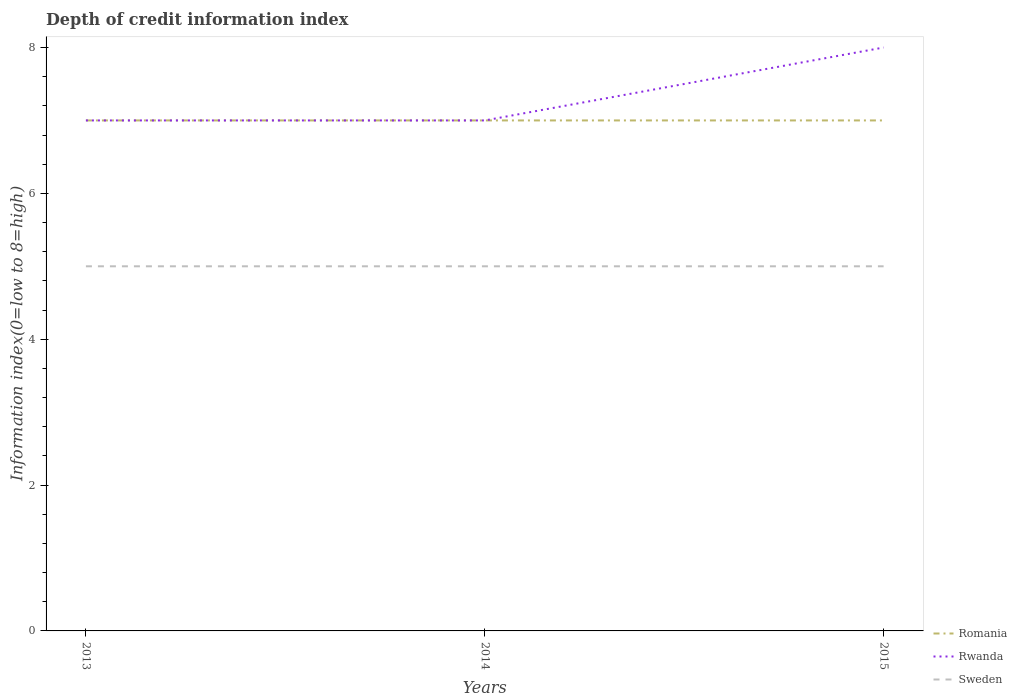How many different coloured lines are there?
Provide a short and direct response. 3. Does the line corresponding to Romania intersect with the line corresponding to Rwanda?
Provide a succinct answer. Yes. Is the number of lines equal to the number of legend labels?
Offer a very short reply. Yes. Across all years, what is the maximum information index in Romania?
Offer a very short reply. 7. What is the difference between the highest and the lowest information index in Romania?
Make the answer very short. 0. How many lines are there?
Make the answer very short. 3. Are the values on the major ticks of Y-axis written in scientific E-notation?
Offer a terse response. No. Does the graph contain any zero values?
Your response must be concise. No. Where does the legend appear in the graph?
Offer a terse response. Bottom right. How many legend labels are there?
Your response must be concise. 3. How are the legend labels stacked?
Keep it short and to the point. Vertical. What is the title of the graph?
Your answer should be compact. Depth of credit information index. What is the label or title of the X-axis?
Provide a short and direct response. Years. What is the label or title of the Y-axis?
Make the answer very short. Information index(0=low to 8=high). What is the Information index(0=low to 8=high) in Romania in 2013?
Provide a short and direct response. 7. What is the Information index(0=low to 8=high) in Sweden in 2013?
Ensure brevity in your answer.  5. What is the Information index(0=low to 8=high) of Romania in 2015?
Make the answer very short. 7. Across all years, what is the maximum Information index(0=low to 8=high) of Rwanda?
Give a very brief answer. 8. Across all years, what is the minimum Information index(0=low to 8=high) in Rwanda?
Provide a short and direct response. 7. What is the difference between the Information index(0=low to 8=high) in Romania in 2013 and that in 2014?
Your answer should be very brief. 0. What is the difference between the Information index(0=low to 8=high) in Sweden in 2013 and that in 2014?
Keep it short and to the point. 0. What is the difference between the Information index(0=low to 8=high) in Romania in 2013 and that in 2015?
Ensure brevity in your answer.  0. What is the difference between the Information index(0=low to 8=high) in Sweden in 2013 and that in 2015?
Ensure brevity in your answer.  0. What is the difference between the Information index(0=low to 8=high) of Sweden in 2014 and that in 2015?
Provide a short and direct response. 0. What is the difference between the Information index(0=low to 8=high) of Romania in 2013 and the Information index(0=low to 8=high) of Rwanda in 2014?
Provide a succinct answer. 0. What is the difference between the Information index(0=low to 8=high) in Rwanda in 2013 and the Information index(0=low to 8=high) in Sweden in 2014?
Provide a short and direct response. 2. What is the difference between the Information index(0=low to 8=high) of Romania in 2013 and the Information index(0=low to 8=high) of Sweden in 2015?
Keep it short and to the point. 2. What is the difference between the Information index(0=low to 8=high) of Rwanda in 2013 and the Information index(0=low to 8=high) of Sweden in 2015?
Provide a succinct answer. 2. What is the difference between the Information index(0=low to 8=high) in Romania in 2014 and the Information index(0=low to 8=high) in Rwanda in 2015?
Keep it short and to the point. -1. What is the difference between the Information index(0=low to 8=high) of Romania in 2014 and the Information index(0=low to 8=high) of Sweden in 2015?
Provide a short and direct response. 2. What is the average Information index(0=low to 8=high) of Romania per year?
Provide a short and direct response. 7. What is the average Information index(0=low to 8=high) of Rwanda per year?
Give a very brief answer. 7.33. What is the average Information index(0=low to 8=high) of Sweden per year?
Ensure brevity in your answer.  5. In the year 2013, what is the difference between the Information index(0=low to 8=high) of Romania and Information index(0=low to 8=high) of Rwanda?
Offer a terse response. 0. In the year 2013, what is the difference between the Information index(0=low to 8=high) of Romania and Information index(0=low to 8=high) of Sweden?
Your response must be concise. 2. In the year 2013, what is the difference between the Information index(0=low to 8=high) in Rwanda and Information index(0=low to 8=high) in Sweden?
Keep it short and to the point. 2. In the year 2014, what is the difference between the Information index(0=low to 8=high) in Romania and Information index(0=low to 8=high) in Sweden?
Offer a terse response. 2. In the year 2015, what is the difference between the Information index(0=low to 8=high) of Romania and Information index(0=low to 8=high) of Sweden?
Make the answer very short. 2. What is the ratio of the Information index(0=low to 8=high) in Romania in 2013 to that in 2014?
Your answer should be compact. 1. What is the ratio of the Information index(0=low to 8=high) in Sweden in 2013 to that in 2015?
Ensure brevity in your answer.  1. What is the ratio of the Information index(0=low to 8=high) of Romania in 2014 to that in 2015?
Offer a very short reply. 1. What is the ratio of the Information index(0=low to 8=high) in Rwanda in 2014 to that in 2015?
Your answer should be compact. 0.88. What is the difference between the highest and the second highest Information index(0=low to 8=high) in Rwanda?
Your answer should be compact. 1. What is the difference between the highest and the second highest Information index(0=low to 8=high) in Sweden?
Offer a terse response. 0. What is the difference between the highest and the lowest Information index(0=low to 8=high) in Romania?
Your answer should be very brief. 0. What is the difference between the highest and the lowest Information index(0=low to 8=high) of Rwanda?
Offer a very short reply. 1. What is the difference between the highest and the lowest Information index(0=low to 8=high) in Sweden?
Make the answer very short. 0. 